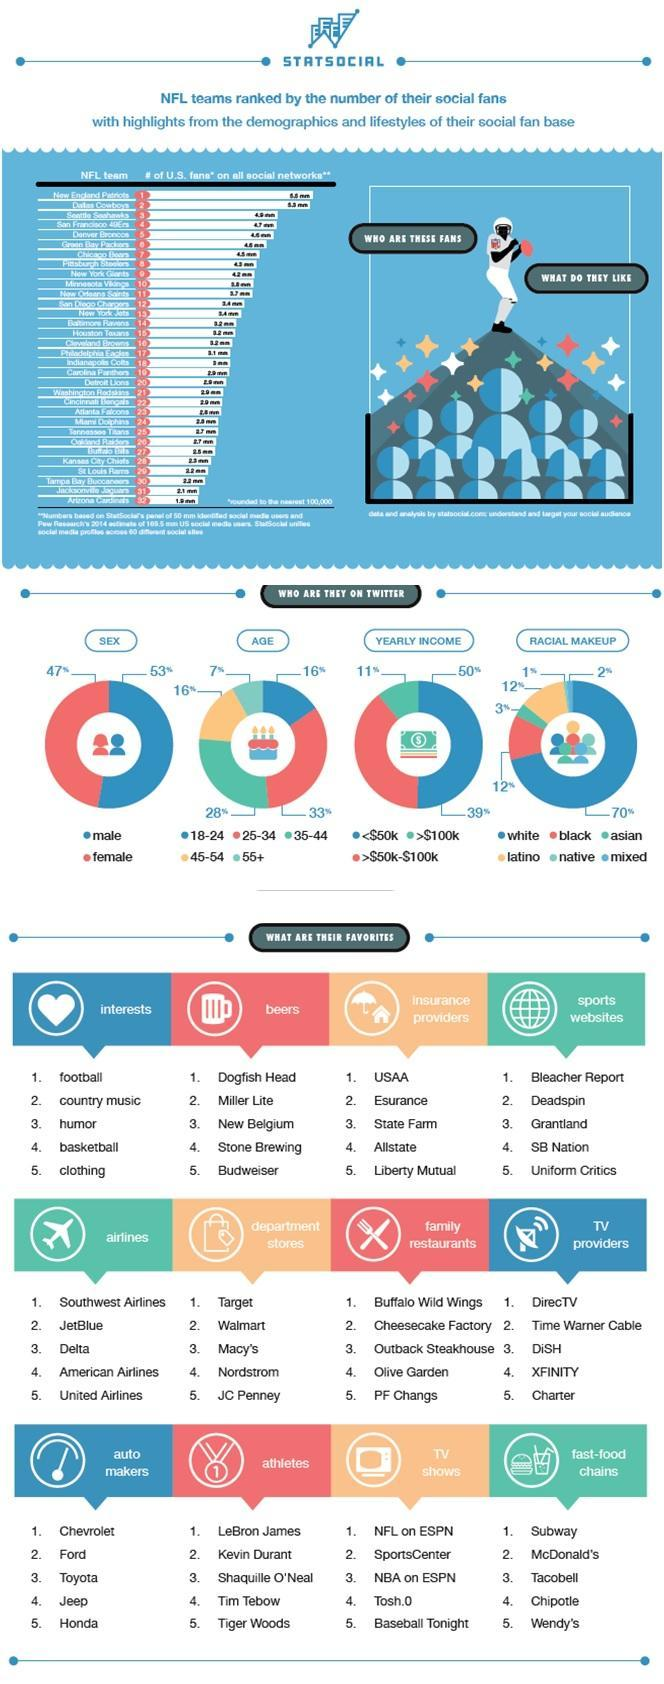What percentage of NFL fans on twitter has a yearly income greater than $100k in the U.S.?
Answer the question with a short phrase. 11% Which is the no.1 favourite sports website of NFL fans in the U.S.? Bleacher Report What percent of NFL fans on twitter are blacks in the U.S.? 12% What percent of NFL fans on twitter are females in the U.S.? 47% What percent of NFL fans on twitter are of the age group 25-34 in the U.S.? 33% What percent of NFL fans on twitter are whites in the U.S.? 70% What percent of NFL fans on twitter are males in the U.S.? 53% Which age group NFL fan followers in U.S are least on the twitter ? 55+ What percent of NFL fans on twitter are of the age group 35-44 in the U.S.? 28% Which is the no.1 favourite fast food chains of NFL fans in the U.S.? Subway 